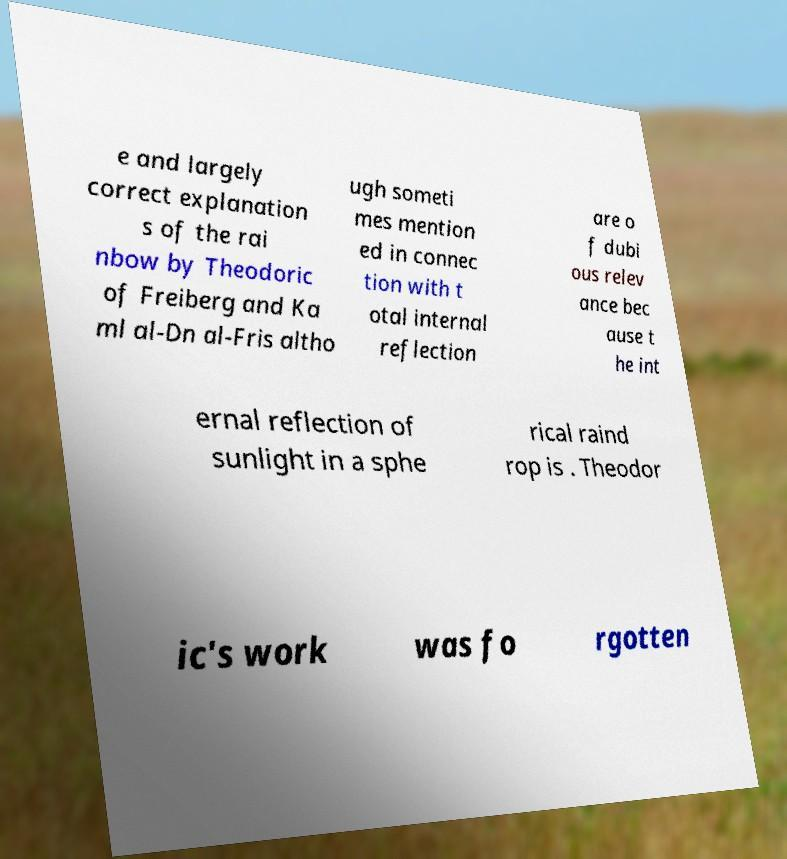Could you assist in decoding the text presented in this image and type it out clearly? e and largely correct explanation s of the rai nbow by Theodoric of Freiberg and Ka ml al-Dn al-Fris altho ugh someti mes mention ed in connec tion with t otal internal reflection are o f dubi ous relev ance bec ause t he int ernal reflection of sunlight in a sphe rical raind rop is . Theodor ic's work was fo rgotten 